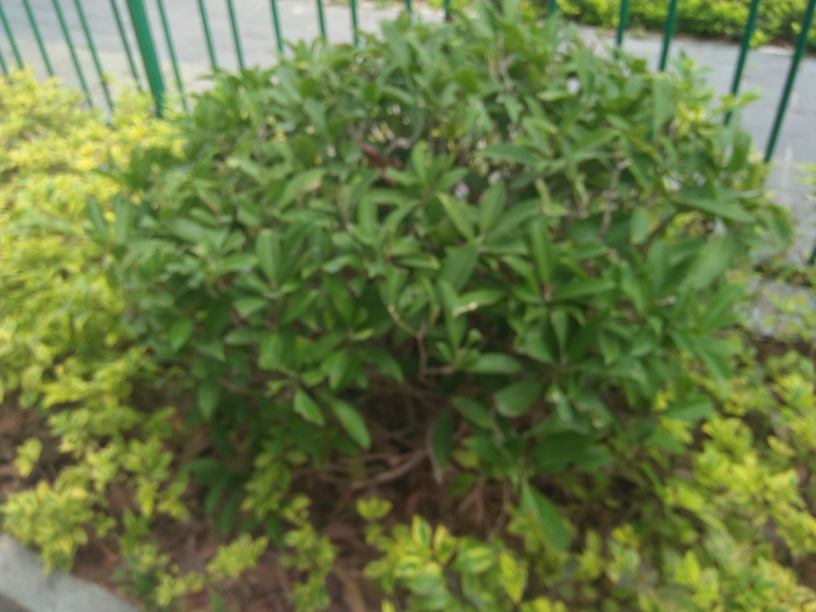How would you describe the lighting in this image? The image appears to suffer from overexposure, resulting in a lighting that seems too harsh and washed out. This diminishes detail and contrast in the photo, affecting the visual quality. 